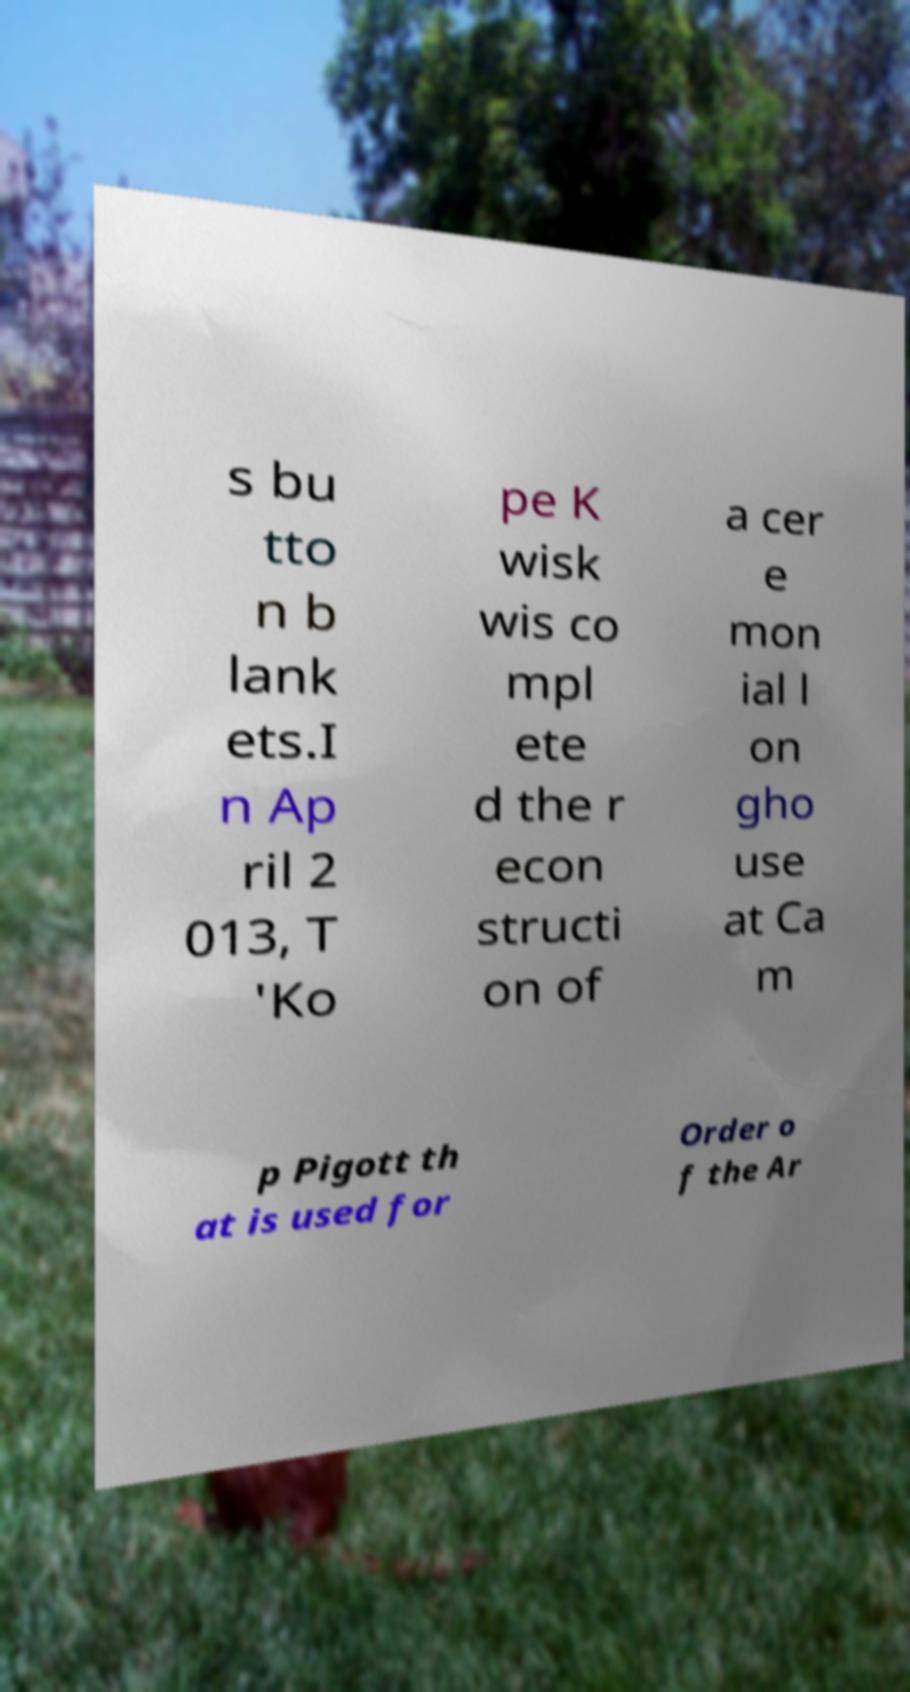Could you extract and type out the text from this image? s bu tto n b lank ets.I n Ap ril 2 013, T 'Ko pe K wisk wis co mpl ete d the r econ structi on of a cer e mon ial l on gho use at Ca m p Pigott th at is used for Order o f the Ar 